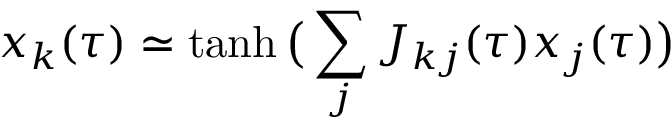<formula> <loc_0><loc_0><loc_500><loc_500>x _ { k } ( \tau ) \simeq t a n h \, \left ( \sum _ { j } J _ { k j } ( \tau ) x _ { j } ( \tau ) \right )</formula> 